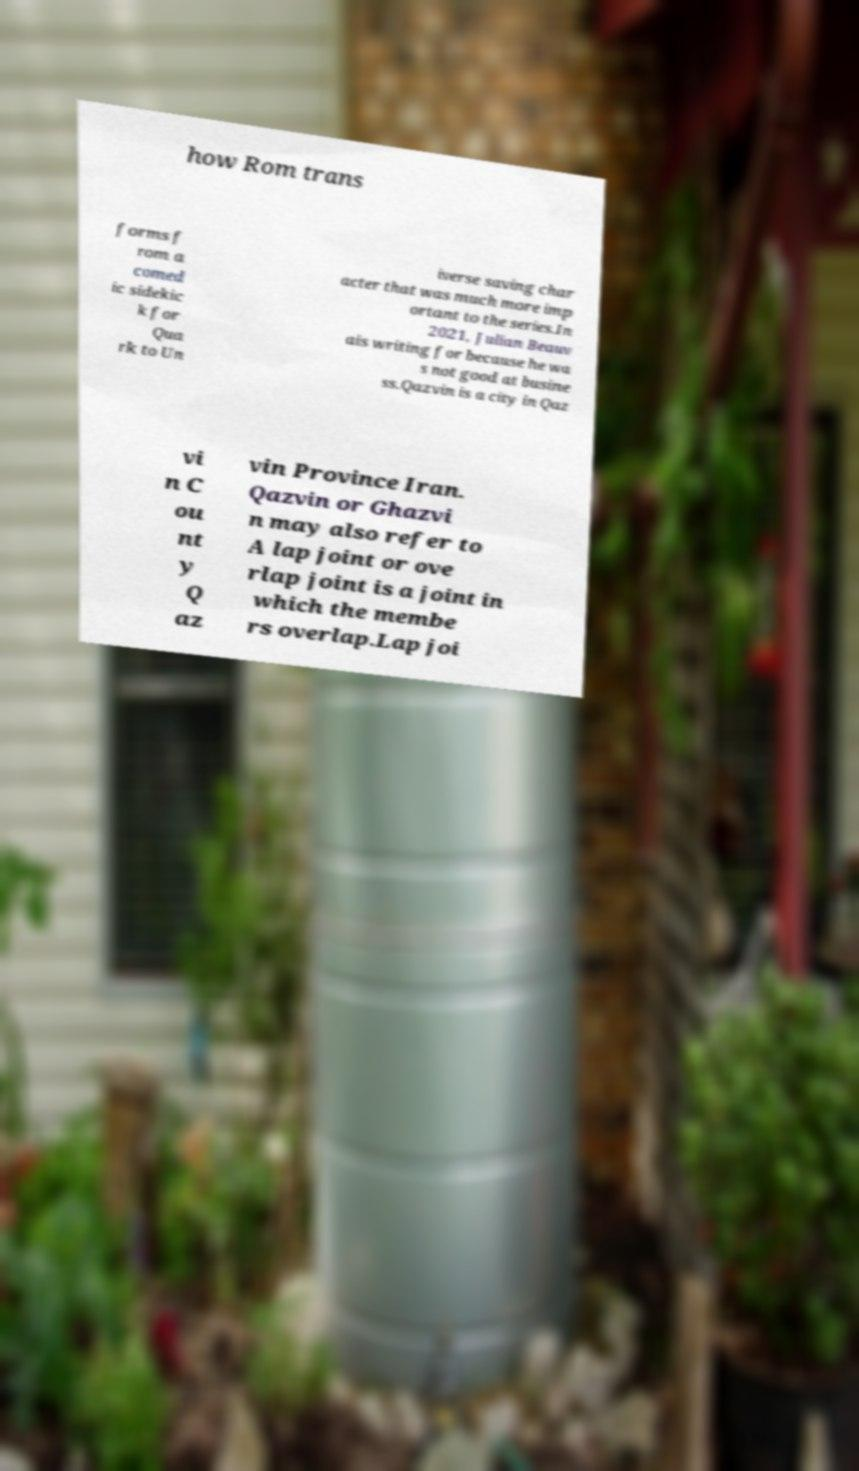Please read and relay the text visible in this image. What does it say? how Rom trans forms f rom a comed ic sidekic k for Qua rk to Un iverse saving char acter that was much more imp ortant to the series.In 2021, Julian Beauv ais writing for because he wa s not good at busine ss.Qazvin is a city in Qaz vi n C ou nt y Q az vin Province Iran. Qazvin or Ghazvi n may also refer to A lap joint or ove rlap joint is a joint in which the membe rs overlap.Lap joi 